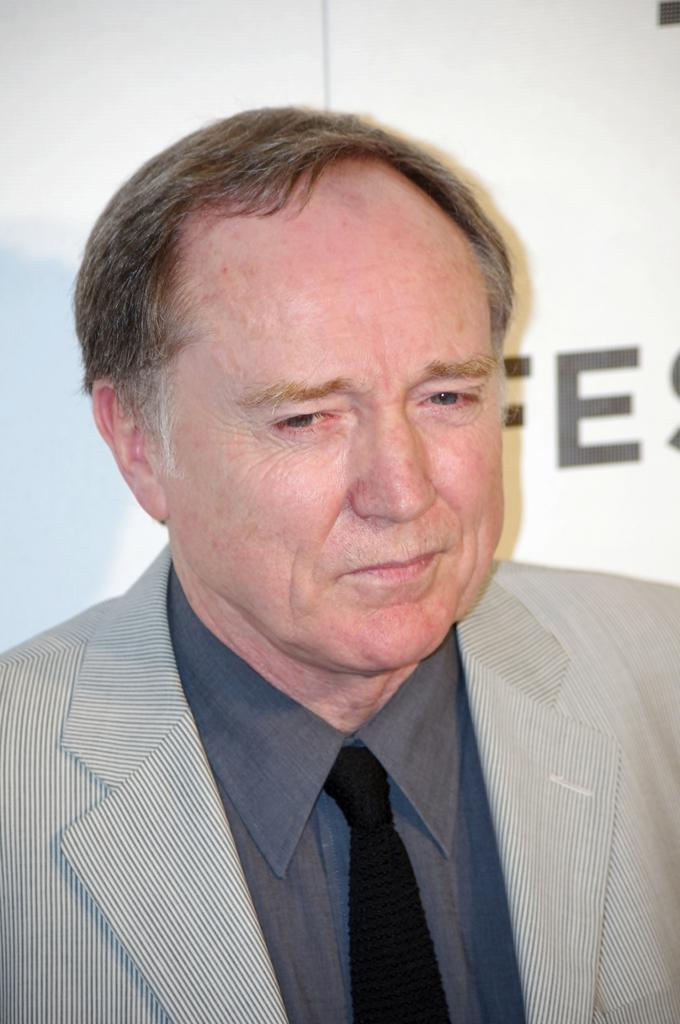Who is present in the image? There is a man in the image. What is the man wearing on his upper body? The man is wearing a coat and a grey shirt. Is there any accessory visible on the man? Yes, the man is wearing a tie. What can be seen in the background of the image? There is a white color banner in the image. What type of twist can be seen in the man's hair in the image? There is no twist visible in the man's hair in the image. What type of writing can be seen on the banner in the image? The provided facts do not mention any writing on the banner, only its color. 